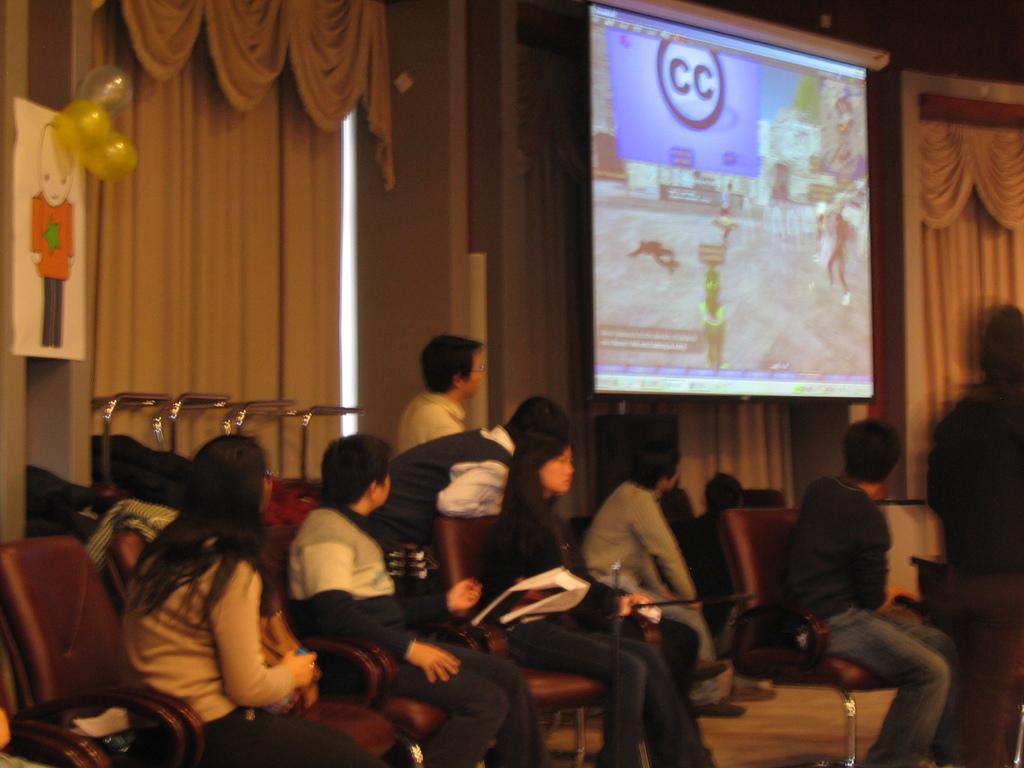How would you summarize this image in a sentence or two? Here people are sitting on the chair watching the screen, here there is curtain. 